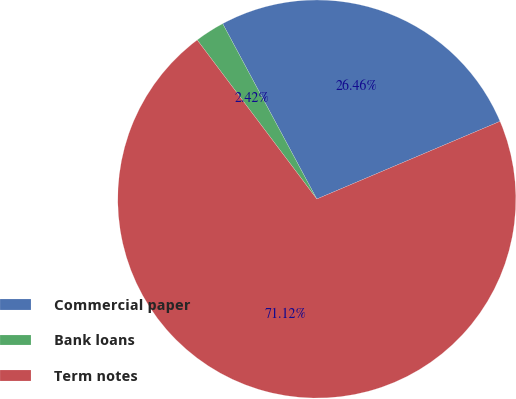Convert chart. <chart><loc_0><loc_0><loc_500><loc_500><pie_chart><fcel>Commercial paper<fcel>Bank loans<fcel>Term notes<nl><fcel>26.46%<fcel>2.42%<fcel>71.12%<nl></chart> 